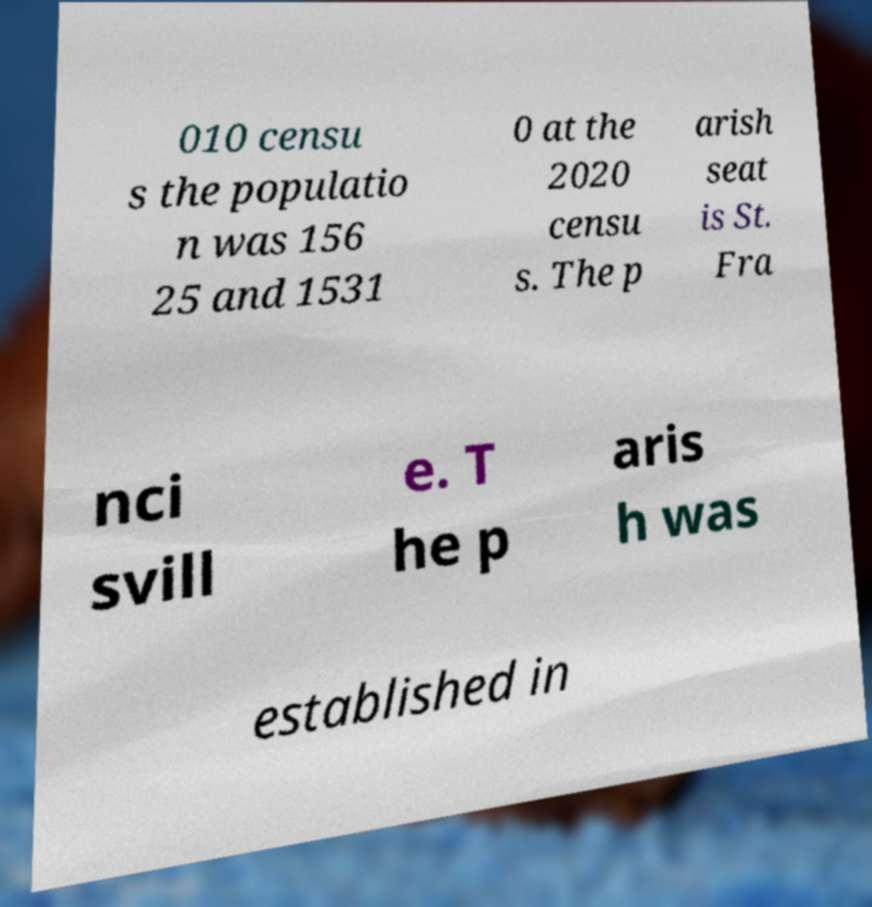Please identify and transcribe the text found in this image. 010 censu s the populatio n was 156 25 and 1531 0 at the 2020 censu s. The p arish seat is St. Fra nci svill e. T he p aris h was established in 